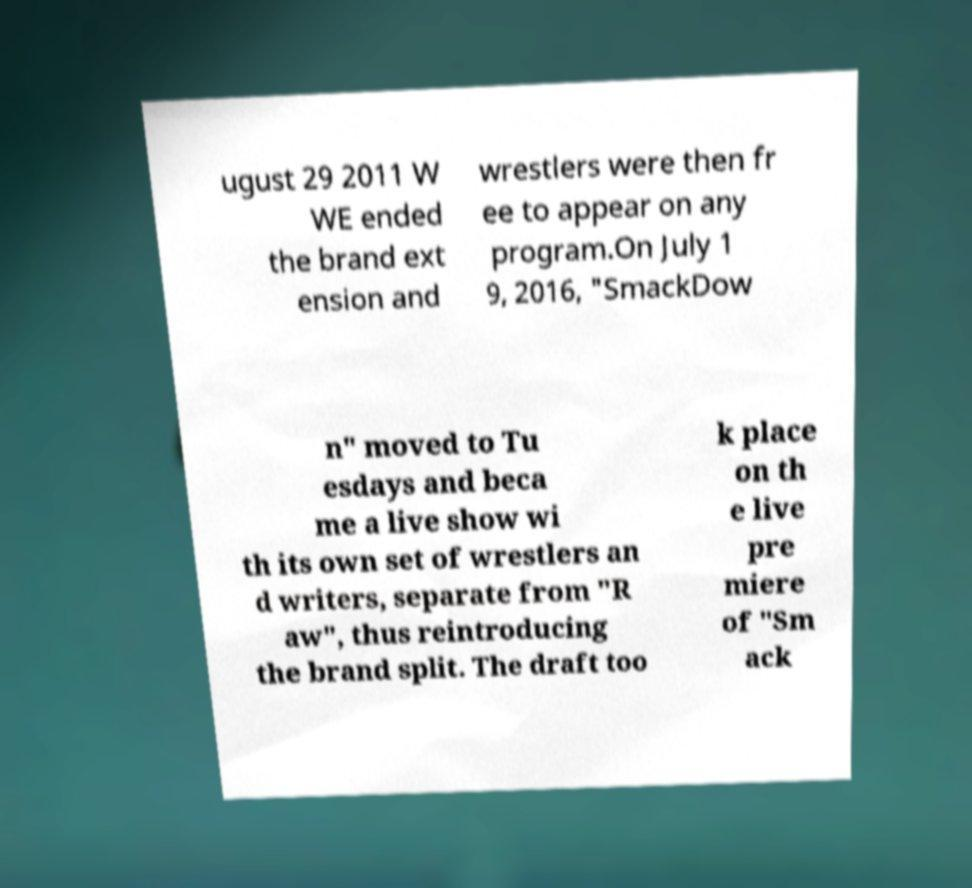I need the written content from this picture converted into text. Can you do that? ugust 29 2011 W WE ended the brand ext ension and wrestlers were then fr ee to appear on any program.On July 1 9, 2016, "SmackDow n" moved to Tu esdays and beca me a live show wi th its own set of wrestlers an d writers, separate from "R aw", thus reintroducing the brand split. The draft too k place on th e live pre miere of "Sm ack 